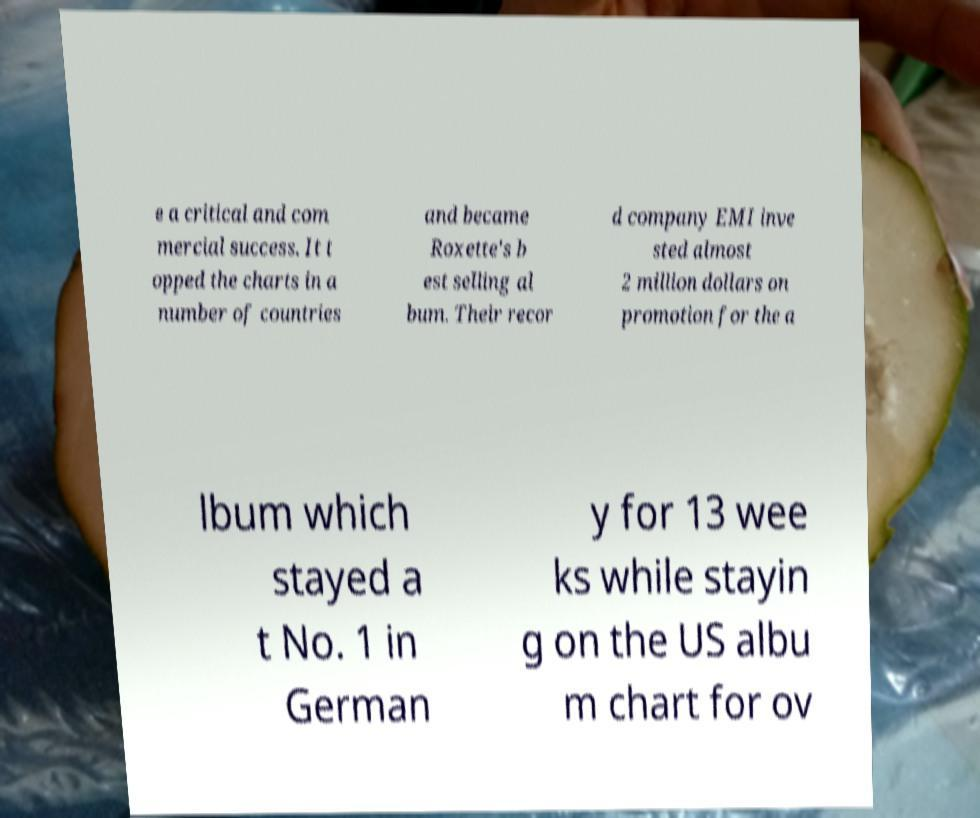Could you assist in decoding the text presented in this image and type it out clearly? e a critical and com mercial success. It t opped the charts in a number of countries and became Roxette's b est selling al bum. Their recor d company EMI inve sted almost 2 million dollars on promotion for the a lbum which stayed a t No. 1 in German y for 13 wee ks while stayin g on the US albu m chart for ov 